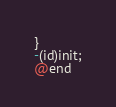Convert code to text. <code><loc_0><loc_0><loc_500><loc_500><_C_>
}
-(id)init;
@end

</code> 